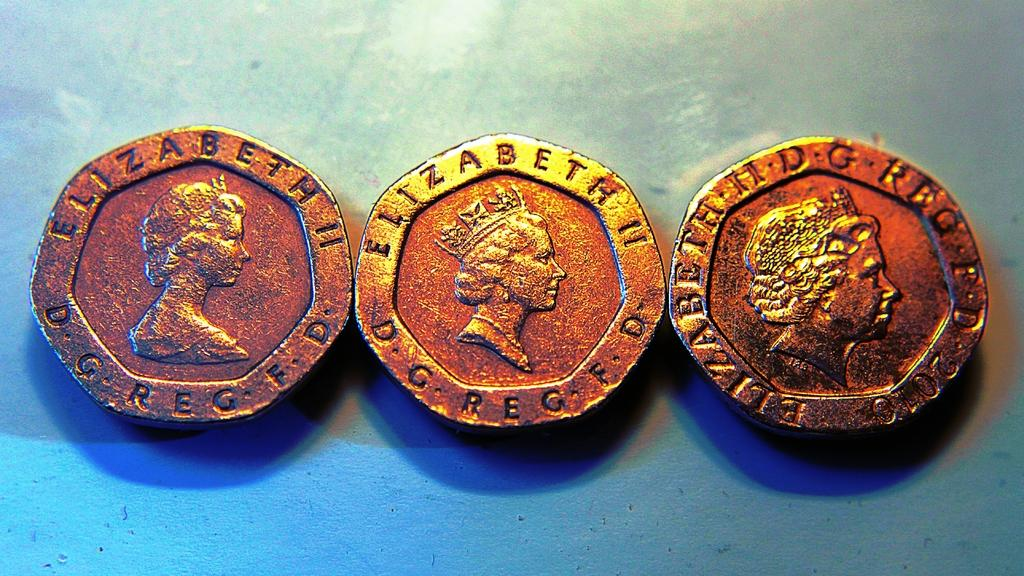<image>
Offer a succinct explanation of the picture presented. Three Elizabeth II coins sit next to each other. 